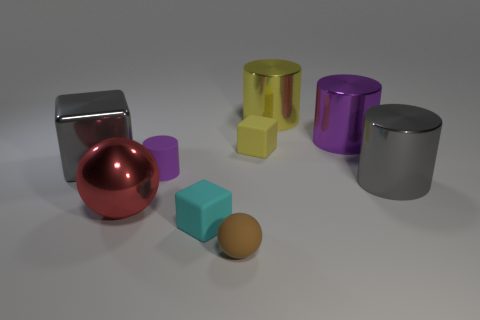Does the small yellow matte object have the same shape as the small cyan object?
Your answer should be compact. Yes. Is the size of the purple thing that is on the left side of the small yellow rubber cube the same as the yellow object that is on the left side of the yellow metallic thing?
Make the answer very short. Yes. What size is the gray object that is the same shape as the tiny purple object?
Offer a terse response. Large. Is the number of tiny purple things behind the small matte cylinder greater than the number of gray metallic cylinders behind the big gray metallic cube?
Provide a short and direct response. No. What is the thing that is in front of the large gray metal cylinder and behind the tiny cyan matte block made of?
Make the answer very short. Metal. The other small thing that is the same shape as the small cyan thing is what color?
Ensure brevity in your answer.  Yellow. The red metallic sphere has what size?
Your response must be concise. Large. What is the color of the small cube in front of the big gray thing on the right side of the small brown matte sphere?
Offer a terse response. Cyan. How many big gray shiny things are right of the gray block and behind the big gray cylinder?
Your response must be concise. 0. Is the number of tiny spheres greater than the number of tiny purple shiny balls?
Your answer should be very brief. Yes. 